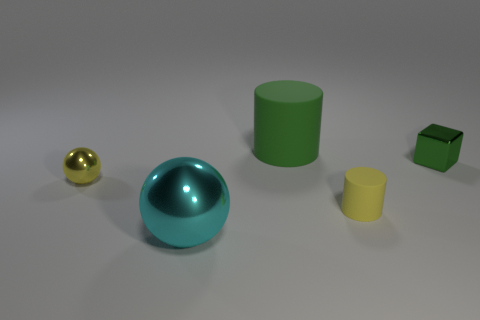Does the small metallic thing on the right side of the green cylinder have the same color as the large object that is in front of the small rubber cylinder?
Make the answer very short. No. What size is the yellow thing that is behind the yellow object that is in front of the small shiny object that is on the left side of the small block?
Provide a succinct answer. Small. There is another matte object that is the same shape as the tiny matte object; what color is it?
Make the answer very short. Green. Are there more small yellow rubber cylinders behind the green metal thing than small metallic cylinders?
Ensure brevity in your answer.  No. There is a green metal object; is its shape the same as the small thing that is in front of the yellow metallic ball?
Provide a short and direct response. No. Is there anything else that is the same size as the yellow sphere?
Your answer should be compact. Yes. What size is the yellow metallic thing that is the same shape as the cyan thing?
Your answer should be compact. Small. Is the number of tiny cylinders greater than the number of metallic things?
Ensure brevity in your answer.  No. Is the shape of the large green thing the same as the yellow rubber thing?
Your response must be concise. Yes. What material is the tiny yellow thing that is on the left side of the ball in front of the yellow sphere?
Your response must be concise. Metal. 